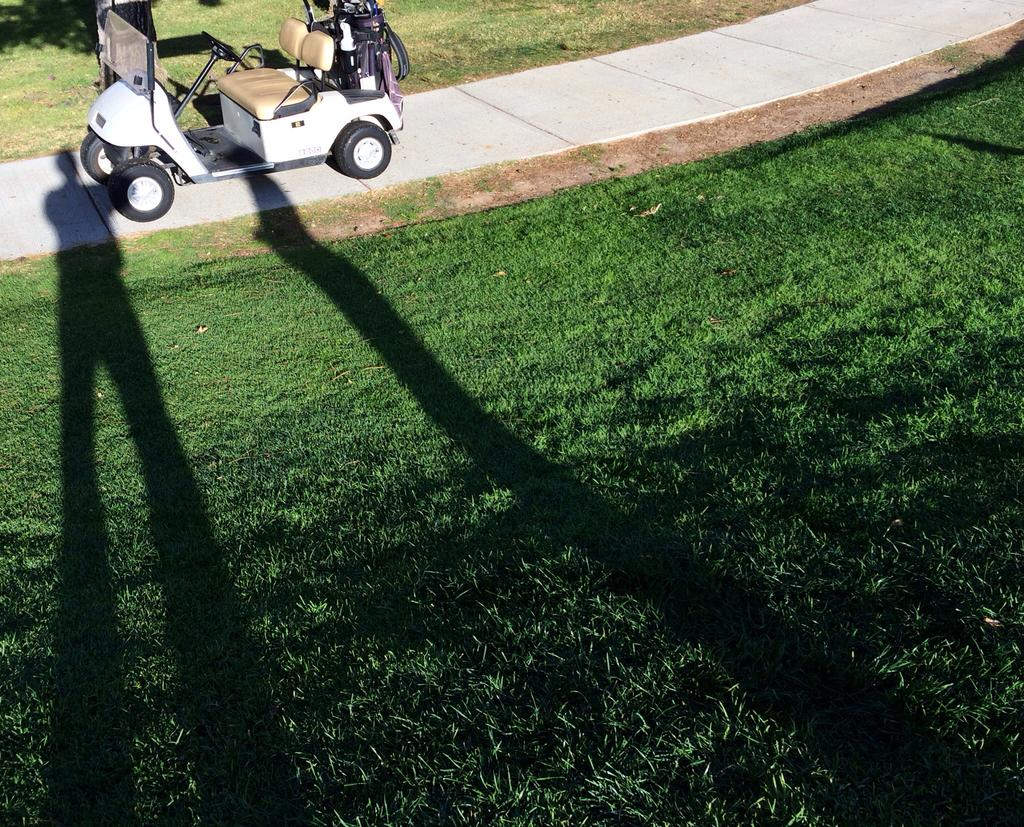What type of vegetation can be seen in the image? There is grass in the image. What can be observed in relation to the lighting in the image? There are shadows in the image. Where is the grass located in the image? At the top of the image, there is grass. What is present on the walkway at the top of the image? A vehicle is present on a walkway at the top of the image. What type of feast is being prepared in the grassy area in the image? There is no indication of a feast being prepared in the image; it only shows grass, shadows, and a vehicle on a walkway. How many cannons are visible in the image? There are no cannons present in the image. 